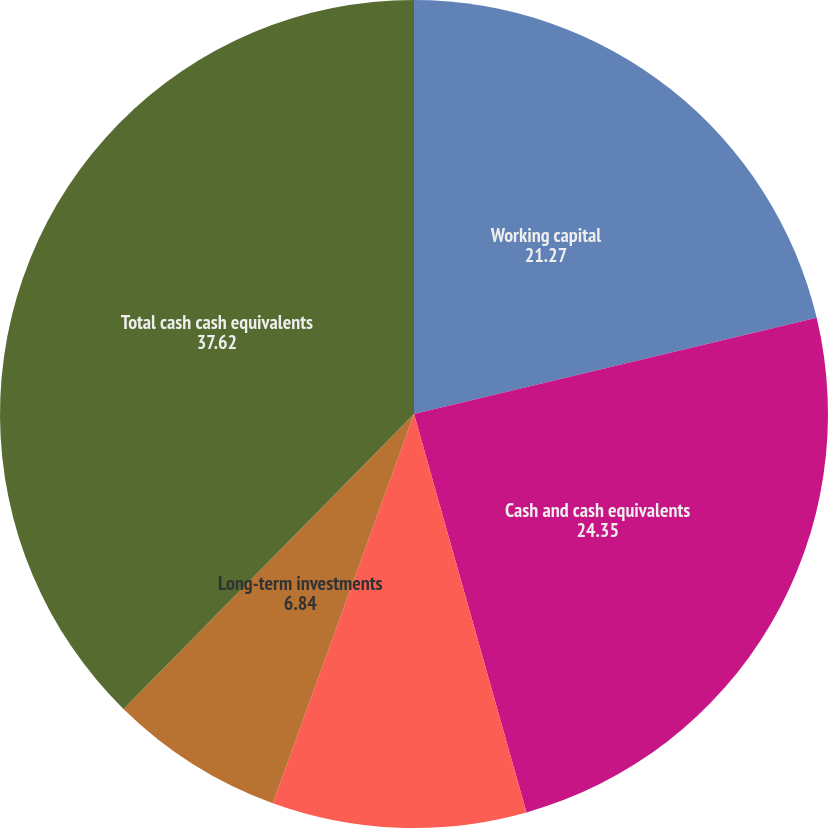<chart> <loc_0><loc_0><loc_500><loc_500><pie_chart><fcel>Working capital<fcel>Cash and cash equivalents<fcel>Short-term investments<fcel>Long-term investments<fcel>Total cash cash equivalents<nl><fcel>21.27%<fcel>24.35%<fcel>9.92%<fcel>6.84%<fcel>37.62%<nl></chart> 